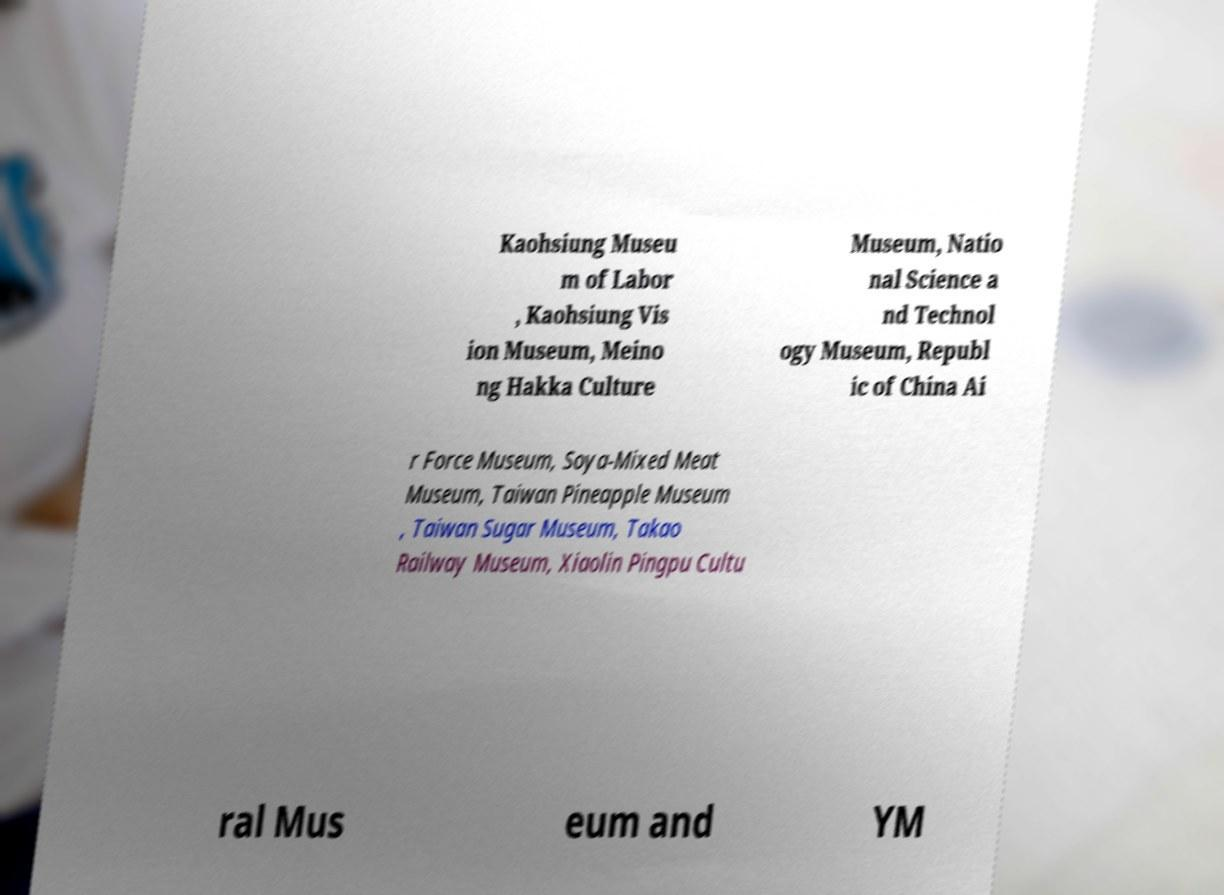What messages or text are displayed in this image? I need them in a readable, typed format. Kaohsiung Museu m of Labor , Kaohsiung Vis ion Museum, Meino ng Hakka Culture Museum, Natio nal Science a nd Technol ogy Museum, Republ ic of China Ai r Force Museum, Soya-Mixed Meat Museum, Taiwan Pineapple Museum , Taiwan Sugar Museum, Takao Railway Museum, Xiaolin Pingpu Cultu ral Mus eum and YM 